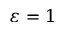<formula> <loc_0><loc_0><loc_500><loc_500>{ \varepsilon } = 1</formula> 